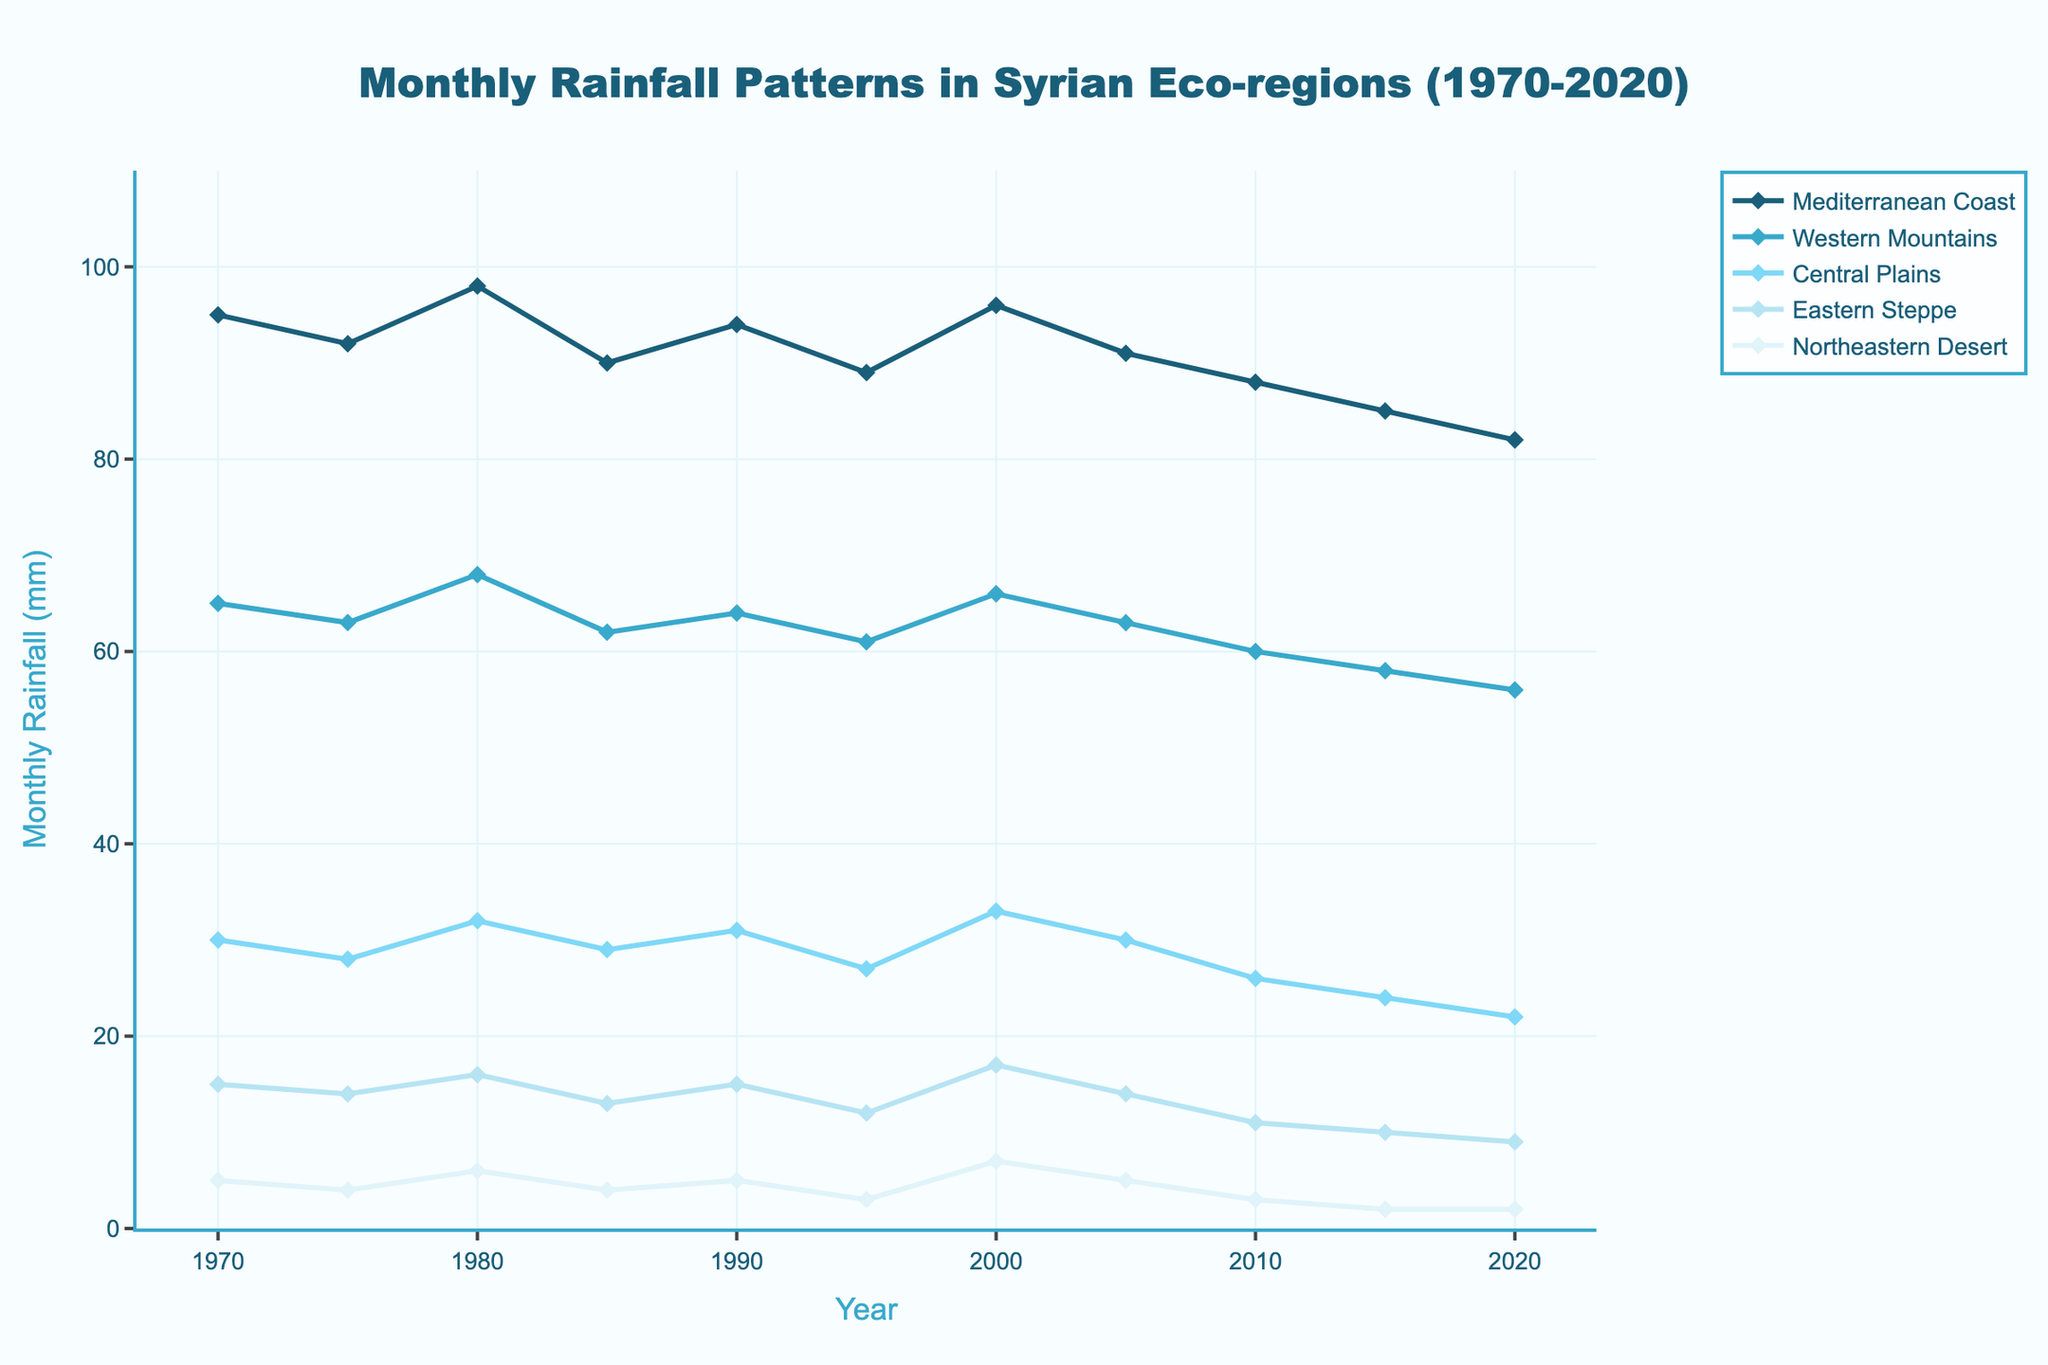What's the average monthly rainfall in the Mediterranean Coast over the 50 years? First, sum the monthly rainfall for the Mediterranean Coast over the 50 years: 95 + 92 + 98 + 90 + 94 + 89 + 96 + 91 + 88 + 85 + 82 = 1000. There are 11 data points, so the average is 1000 / 11.
Answer: 90.91 Which region had the highest monthly rainfall in 1980? Look at the 1980 data across all regions and compare the values. The Mediterranean Coast has 98 mm, the Western Mountains 68 mm, Central Plains 32 mm, Eastern Steppe 16 mm, and Northeastern Desert 6 mm. The highest value is for the Mediterranean Coast.
Answer: Mediterranean Coast Between which years did the Northeastern Desert experience the largest decrease in monthly rainfall? Compare the monthly rainfall values for the Northeastern Desert for each consecutive year pair. The largest decrease is between 2010 (3 mm) and 2015 (2 mm) and also between 2015 (2 mm) and 2020 (2 mm).
Answer: 2010 to 2015 By how many millimeters did the monthly rainfall in the Western Mountains change from 1970 to 2020? Subtract the 2020 value for the Western Mountains from the 1970 value: 65 mm (1970) - 56 mm (2020).
Answer: 9 mm Which region shows the most consistent monthly rainfall over the 50 years? Examine the fluctuations in the rainfall patterns for each region. The Mediterranean Coast and Central Plains show relatively smaller variations compared to other regions. Detailed comparison shows that the Central Plains have smaller variability.
Answer: Central Plains What is the difference in monthly rainfall between the Mediterranean Coast and Eastern Steppe in 1990? Subtract the Eastern Steppe's rainfall from the Mediterranean Coast's rainfall for 1990: 94 mm (Mediterranean Coast) - 15 mm (Eastern Steppe).
Answer: 79 mm Which year had the lowest monthly rainfall for the Central Plains and what was the value? Examine the data for Central Plains across all years and identify the lowest value which is 22 mm in 2020.
Answer: 2020, 22 mm How did the average monthly rainfall in the Western Mountains change from the decades 1970-1980 to 2010-2020? Calculate average rainfall for Western Mountains for the periods 1970-1980: (65 + 63 + 68) / 3 = 65.33 mm, and for 2010-2020: (60 + 58 + 56) / 3 = 58 mm. Compare these values to see the change.
Answer: Decreased by 7.33 mm Which regions experienced a visible decrease in monthly rainfall from 2000 to 2020? Compare the monthly rainfall for each region between 2000 and 2020: Mediterranean Coast from 96 to 82 mm, Western Mountains from 66 to 56 mm, Central Plains from 33 to 22 mm, Eastern Steppe from 17 to 9 mm, and Northeastern Desert from 7 to 2 mm. All regions show a decrease.
Answer: All regions 